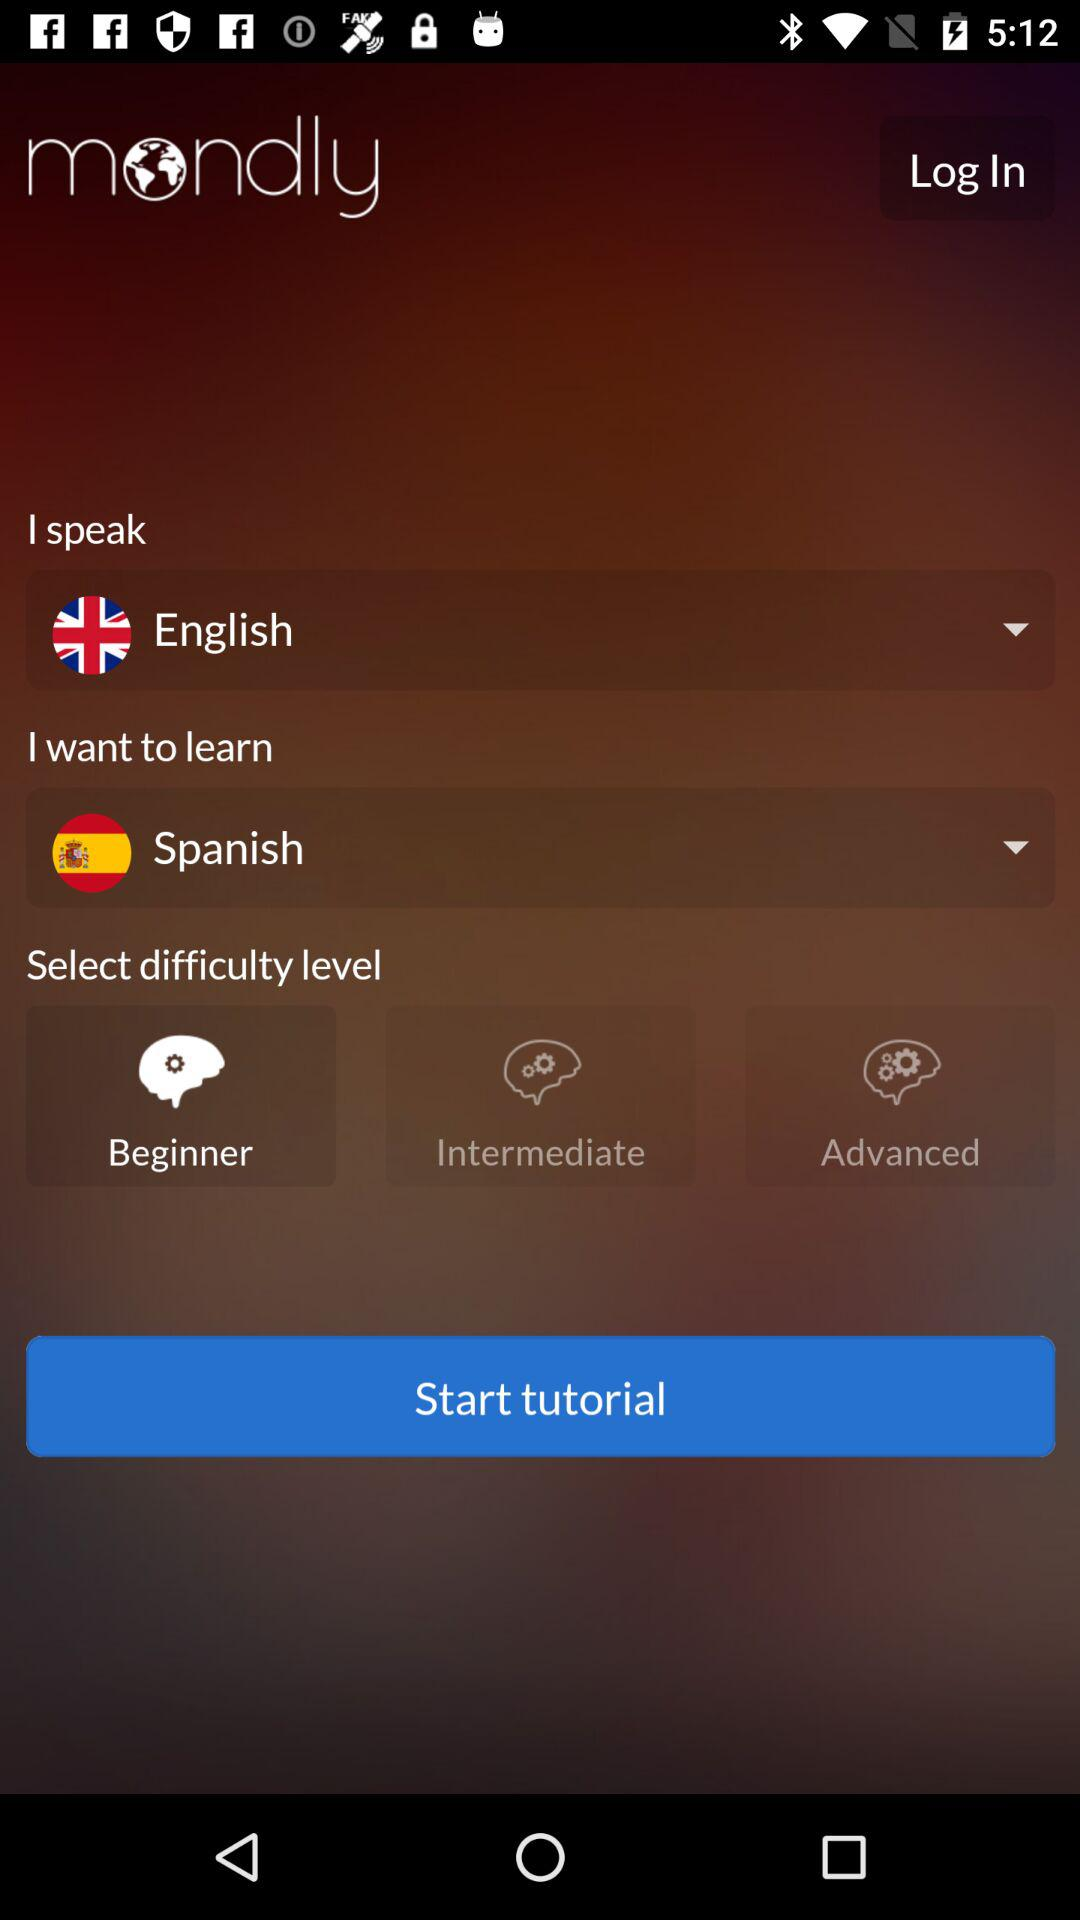How many difficulty levels are there?
Answer the question using a single word or phrase. 3 